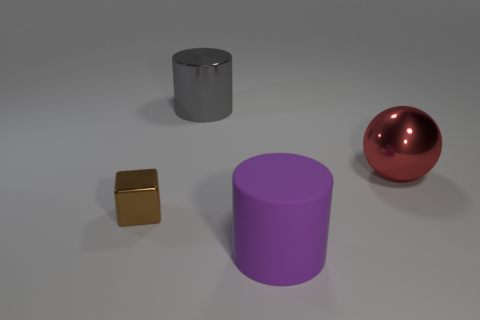Is there anything else that is made of the same material as the large purple cylinder?
Keep it short and to the point. No. Does the small thing have the same material as the purple thing?
Your response must be concise. No. Are there any blue cubes of the same size as the purple thing?
Provide a succinct answer. No. There is a red thing that is the same size as the purple matte object; what is its material?
Your answer should be very brief. Metal. Are there any other rubber things that have the same shape as the purple object?
Keep it short and to the point. No. There is a big thing that is in front of the block; what shape is it?
Offer a terse response. Cylinder. What number of big cylinders are there?
Your answer should be very brief. 2. The large cylinder that is the same material as the small brown block is what color?
Give a very brief answer. Gray. How many large things are gray things or purple matte objects?
Your response must be concise. 2. There is a large metal ball; how many small brown metal things are to the right of it?
Your response must be concise. 0. 